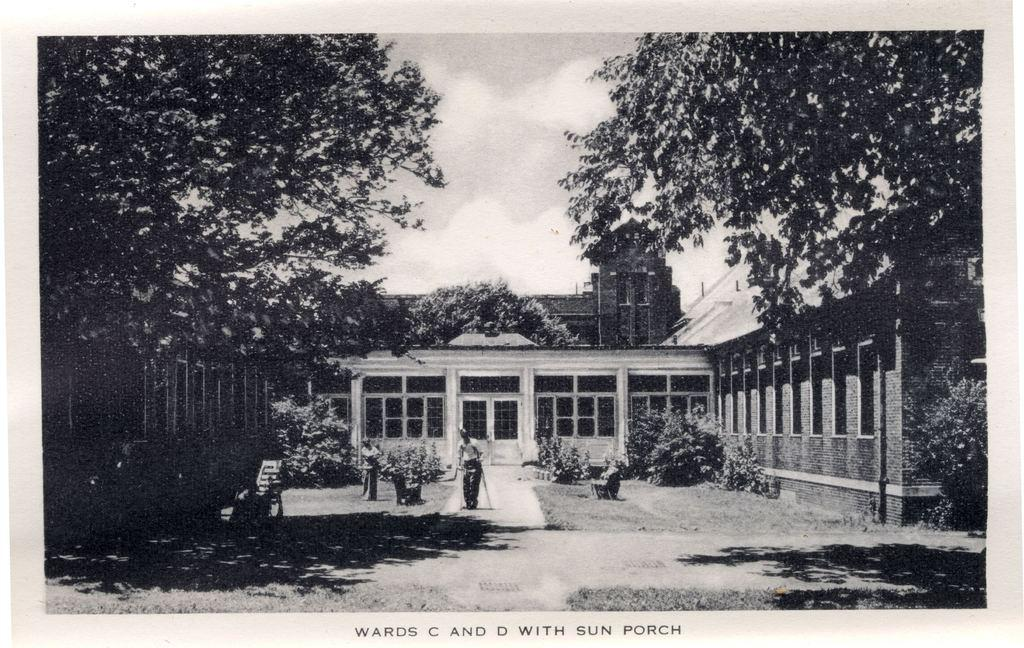<image>
Present a compact description of the photo's key features. A black and white photograph of a house has the words Wards C and D With Sun Porch written beneath it. 